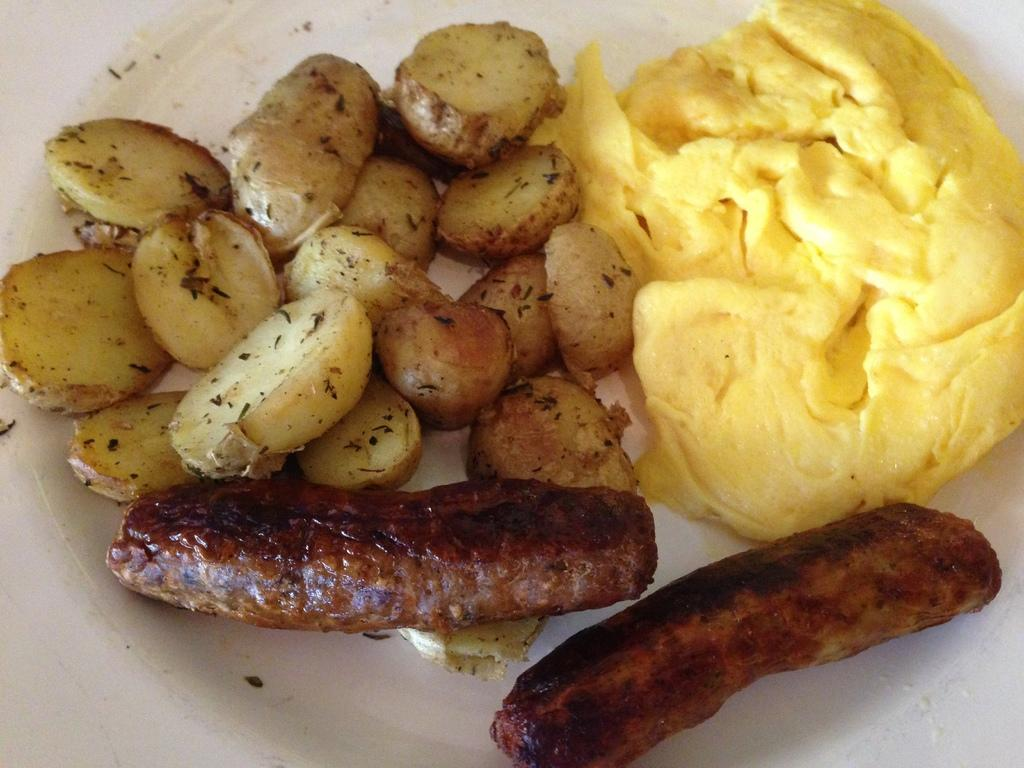What object is present in the image that typically holds food? There is a plate in the image. What type of food can be seen on the plate? The plate contains two hot dogs and potato pieces. Is there any sauce or condiment on the plate? Yes, there is cream on the plate. Can you see any grass growing on the plate in the image? No, there is no grass present on the plate in the image. 